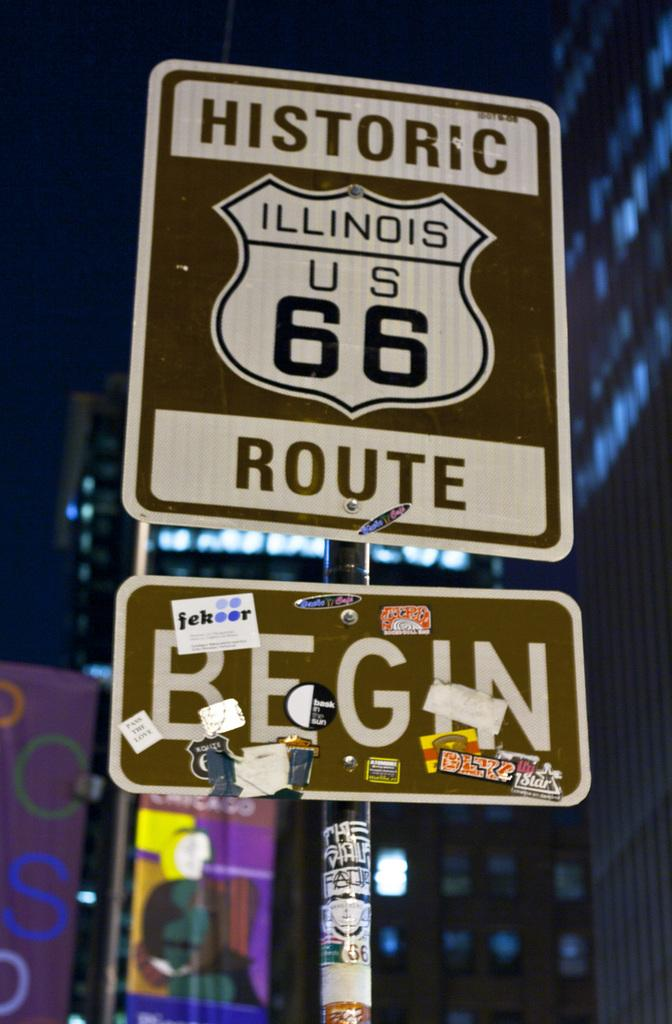<image>
Offer a succinct explanation of the picture presented. A brown, black and white sign that reads historic Rout 66 begin here. 